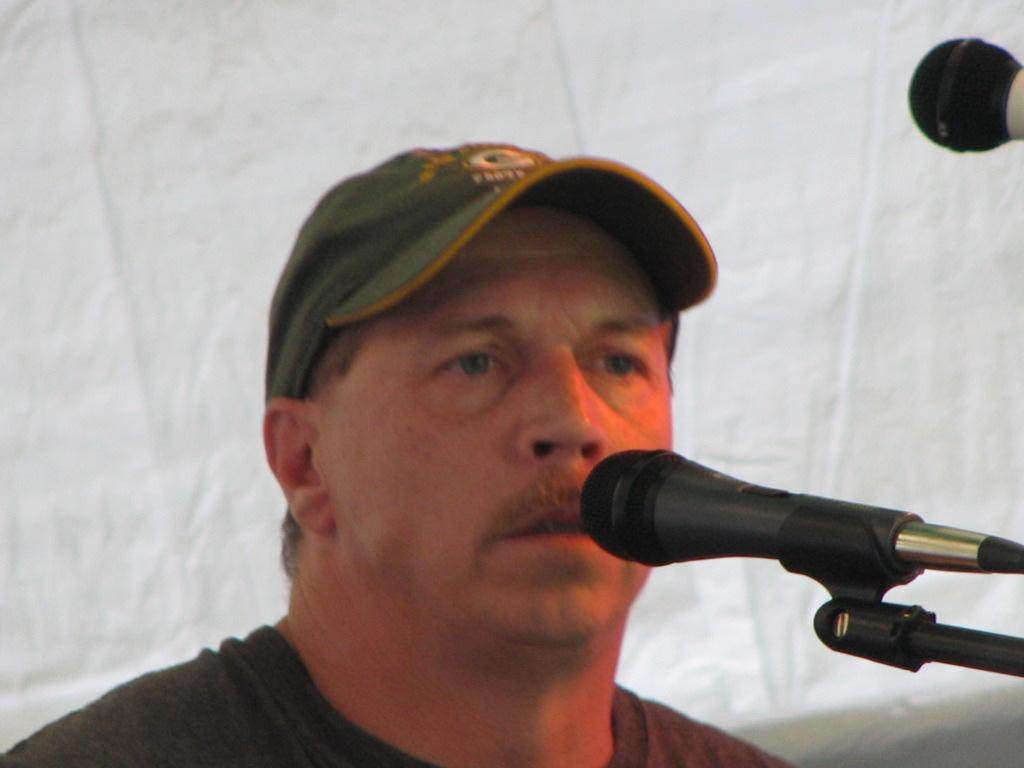Who is present in the image? There is a man in the image. What is the man wearing on his head? The man is wearing a hat. What objects can be seen on the right side of the image? There are two microphones on the right side of the image. What type of toy is the man holding in the image? There is no toy present in the image; the man is not holding anything. 